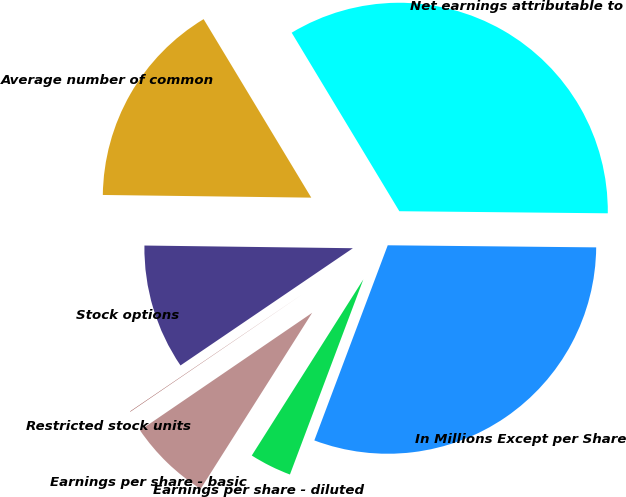Convert chart to OTSL. <chart><loc_0><loc_0><loc_500><loc_500><pie_chart><fcel>In Millions Except per Share<fcel>Net earnings attributable to<fcel>Average number of common<fcel>Stock options<fcel>Restricted stock units<fcel>Earnings per share - basic<fcel>Earnings per share - diluted<nl><fcel>30.57%<fcel>33.8%<fcel>16.16%<fcel>9.71%<fcel>0.03%<fcel>6.48%<fcel>3.26%<nl></chart> 